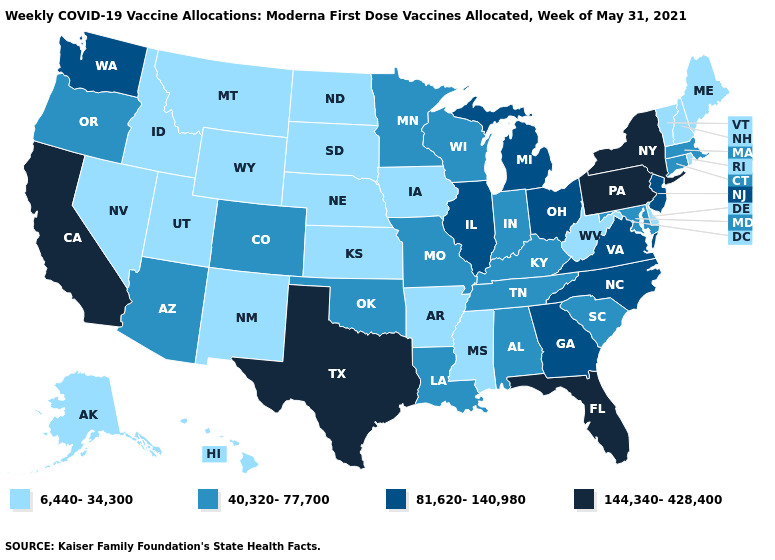What is the value of Pennsylvania?
Concise answer only. 144,340-428,400. What is the lowest value in states that border New Jersey?
Give a very brief answer. 6,440-34,300. Name the states that have a value in the range 81,620-140,980?
Quick response, please. Georgia, Illinois, Michigan, New Jersey, North Carolina, Ohio, Virginia, Washington. Which states have the lowest value in the USA?
Quick response, please. Alaska, Arkansas, Delaware, Hawaii, Idaho, Iowa, Kansas, Maine, Mississippi, Montana, Nebraska, Nevada, New Hampshire, New Mexico, North Dakota, Rhode Island, South Dakota, Utah, Vermont, West Virginia, Wyoming. Name the states that have a value in the range 6,440-34,300?
Concise answer only. Alaska, Arkansas, Delaware, Hawaii, Idaho, Iowa, Kansas, Maine, Mississippi, Montana, Nebraska, Nevada, New Hampshire, New Mexico, North Dakota, Rhode Island, South Dakota, Utah, Vermont, West Virginia, Wyoming. Does West Virginia have the highest value in the USA?
Concise answer only. No. What is the highest value in the USA?
Write a very short answer. 144,340-428,400. Name the states that have a value in the range 40,320-77,700?
Give a very brief answer. Alabama, Arizona, Colorado, Connecticut, Indiana, Kentucky, Louisiana, Maryland, Massachusetts, Minnesota, Missouri, Oklahoma, Oregon, South Carolina, Tennessee, Wisconsin. Does Florida have the lowest value in the South?
Answer briefly. No. Among the states that border Wyoming , which have the lowest value?
Concise answer only. Idaho, Montana, Nebraska, South Dakota, Utah. Does the map have missing data?
Give a very brief answer. No. Does Rhode Island have a higher value than Colorado?
Be succinct. No. Does the map have missing data?
Give a very brief answer. No. What is the value of Pennsylvania?
Write a very short answer. 144,340-428,400. 